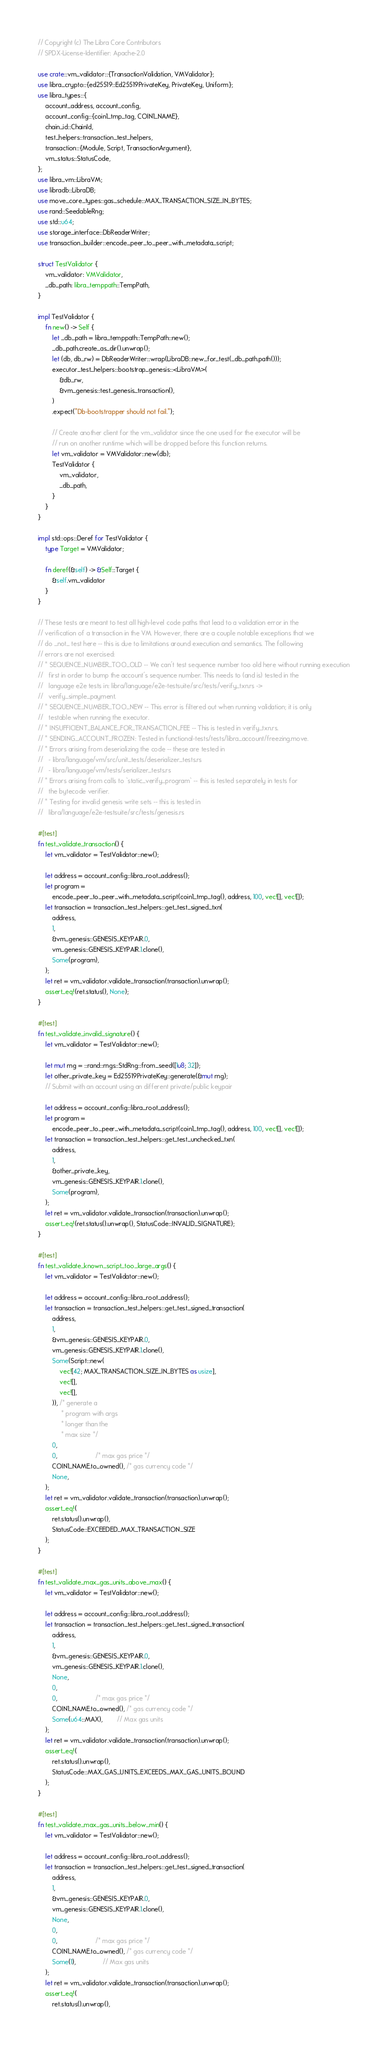<code> <loc_0><loc_0><loc_500><loc_500><_Rust_>// Copyright (c) The Libra Core Contributors
// SPDX-License-Identifier: Apache-2.0

use crate::vm_validator::{TransactionValidation, VMValidator};
use libra_crypto::{ed25519::Ed25519PrivateKey, PrivateKey, Uniform};
use libra_types::{
    account_address, account_config,
    account_config::{coin1_tmp_tag, COIN1_NAME},
    chain_id::ChainId,
    test_helpers::transaction_test_helpers,
    transaction::{Module, Script, TransactionArgument},
    vm_status::StatusCode,
};
use libra_vm::LibraVM;
use libradb::LibraDB;
use move_core_types::gas_schedule::MAX_TRANSACTION_SIZE_IN_BYTES;
use rand::SeedableRng;
use std::u64;
use storage_interface::DbReaderWriter;
use transaction_builder::encode_peer_to_peer_with_metadata_script;

struct TestValidator {
    vm_validator: VMValidator,
    _db_path: libra_temppath::TempPath,
}

impl TestValidator {
    fn new() -> Self {
        let _db_path = libra_temppath::TempPath::new();
        _db_path.create_as_dir().unwrap();
        let (db, db_rw) = DbReaderWriter::wrap(LibraDB::new_for_test(_db_path.path()));
        executor_test_helpers::bootstrap_genesis::<LibraVM>(
            &db_rw,
            &vm_genesis::test_genesis_transaction(),
        )
        .expect("Db-bootstrapper should not fail.");

        // Create another client for the vm_validator since the one used for the executor will be
        // run on another runtime which will be dropped before this function returns.
        let vm_validator = VMValidator::new(db);
        TestValidator {
            vm_validator,
            _db_path,
        }
    }
}

impl std::ops::Deref for TestValidator {
    type Target = VMValidator;

    fn deref(&self) -> &Self::Target {
        &self.vm_validator
    }
}

// These tests are meant to test all high-level code paths that lead to a validation error in the
// verification of a transaction in the VM. However, there are a couple notable exceptions that we
// do _not_ test here -- this is due to limitations around execution and semantics. The following
// errors are not exercised:
// * SEQUENCE_NUMBER_TOO_OLD -- We can't test sequence number too old here without running execution
//   first in order to bump the account's sequence number. This needs to (and is) tested in the
//   language e2e tests in: libra/language/e2e-testsuite/src/tests/verify_txn.rs ->
//   verify_simple_payment.
// * SEQUENCE_NUMBER_TOO_NEW -- This error is filtered out when running validation; it is only
//   testable when running the executor.
// * INSUFFICIENT_BALANCE_FOR_TRANSACTION_FEE -- This is tested in verify_txn.rs.
// * SENDING_ACCOUNT_FROZEN: Tested in functional-tests/tests/libra_account/freezing.move.
// * Errors arising from deserializing the code -- these are tested in
//   - libra/language/vm/src/unit_tests/deserializer_tests.rs
//   - libra/language/vm/tests/serializer_tests.rs
// * Errors arising from calls to `static_verify_program` -- this is tested separately in tests for
//   the bytecode verifier.
// * Testing for invalid genesis write sets -- this is tested in
//   libra/language/e2e-testsuite/src/tests/genesis.rs

#[test]
fn test_validate_transaction() {
    let vm_validator = TestValidator::new();

    let address = account_config::libra_root_address();
    let program =
        encode_peer_to_peer_with_metadata_script(coin1_tmp_tag(), address, 100, vec![], vec![]);
    let transaction = transaction_test_helpers::get_test_signed_txn(
        address,
        1,
        &vm_genesis::GENESIS_KEYPAIR.0,
        vm_genesis::GENESIS_KEYPAIR.1.clone(),
        Some(program),
    );
    let ret = vm_validator.validate_transaction(transaction).unwrap();
    assert_eq!(ret.status(), None);
}

#[test]
fn test_validate_invalid_signature() {
    let vm_validator = TestValidator::new();

    let mut rng = ::rand::rngs::StdRng::from_seed([1u8; 32]);
    let other_private_key = Ed25519PrivateKey::generate(&mut rng);
    // Submit with an account using an different private/public keypair

    let address = account_config::libra_root_address();
    let program =
        encode_peer_to_peer_with_metadata_script(coin1_tmp_tag(), address, 100, vec![], vec![]);
    let transaction = transaction_test_helpers::get_test_unchecked_txn(
        address,
        1,
        &other_private_key,
        vm_genesis::GENESIS_KEYPAIR.1.clone(),
        Some(program),
    );
    let ret = vm_validator.validate_transaction(transaction).unwrap();
    assert_eq!(ret.status().unwrap(), StatusCode::INVALID_SIGNATURE);
}

#[test]
fn test_validate_known_script_too_large_args() {
    let vm_validator = TestValidator::new();

    let address = account_config::libra_root_address();
    let transaction = transaction_test_helpers::get_test_signed_transaction(
        address,
        1,
        &vm_genesis::GENESIS_KEYPAIR.0,
        vm_genesis::GENESIS_KEYPAIR.1.clone(),
        Some(Script::new(
            vec![42; MAX_TRANSACTION_SIZE_IN_BYTES as usize],
            vec![],
            vec![],
        )), /* generate a
             * program with args
             * longer than the
             * max size */
        0,
        0,                     /* max gas price */
        COIN1_NAME.to_owned(), /* gas currency code */
        None,
    );
    let ret = vm_validator.validate_transaction(transaction).unwrap();
    assert_eq!(
        ret.status().unwrap(),
        StatusCode::EXCEEDED_MAX_TRANSACTION_SIZE
    );
}

#[test]
fn test_validate_max_gas_units_above_max() {
    let vm_validator = TestValidator::new();

    let address = account_config::libra_root_address();
    let transaction = transaction_test_helpers::get_test_signed_transaction(
        address,
        1,
        &vm_genesis::GENESIS_KEYPAIR.0,
        vm_genesis::GENESIS_KEYPAIR.1.clone(),
        None,
        0,
        0,                     /* max gas price */
        COIN1_NAME.to_owned(), /* gas currency code */
        Some(u64::MAX),        // Max gas units
    );
    let ret = vm_validator.validate_transaction(transaction).unwrap();
    assert_eq!(
        ret.status().unwrap(),
        StatusCode::MAX_GAS_UNITS_EXCEEDS_MAX_GAS_UNITS_BOUND
    );
}

#[test]
fn test_validate_max_gas_units_below_min() {
    let vm_validator = TestValidator::new();

    let address = account_config::libra_root_address();
    let transaction = transaction_test_helpers::get_test_signed_transaction(
        address,
        1,
        &vm_genesis::GENESIS_KEYPAIR.0,
        vm_genesis::GENESIS_KEYPAIR.1.clone(),
        None,
        0,
        0,                     /* max gas price */
        COIN1_NAME.to_owned(), /* gas currency code */
        Some(1),               // Max gas units
    );
    let ret = vm_validator.validate_transaction(transaction).unwrap();
    assert_eq!(
        ret.status().unwrap(),</code> 